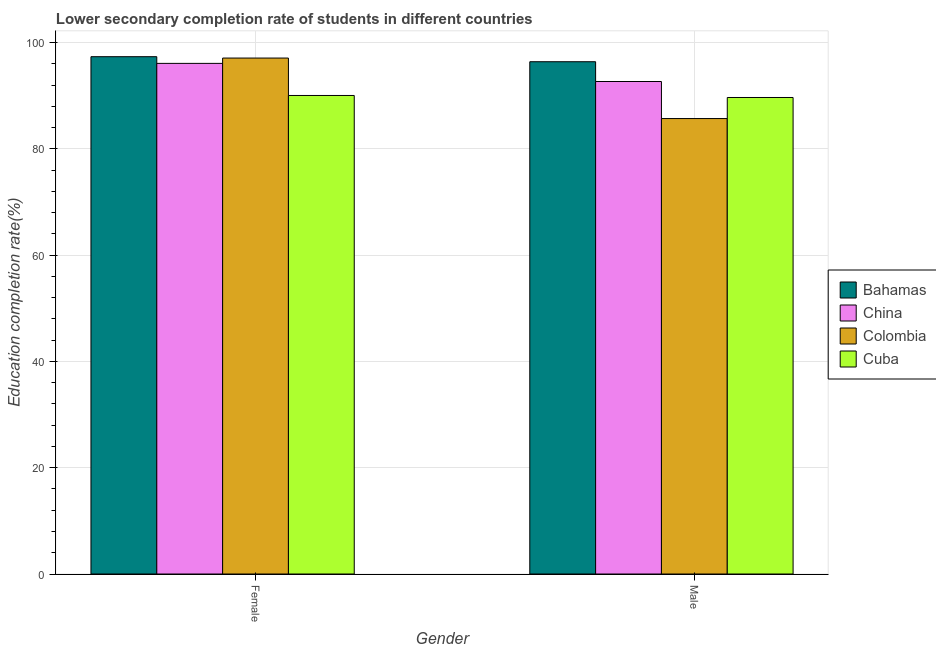How many different coloured bars are there?
Your answer should be very brief. 4. How many bars are there on the 1st tick from the left?
Your answer should be very brief. 4. How many bars are there on the 1st tick from the right?
Your answer should be compact. 4. What is the education completion rate of male students in China?
Your answer should be very brief. 92.69. Across all countries, what is the maximum education completion rate of male students?
Keep it short and to the point. 96.41. Across all countries, what is the minimum education completion rate of male students?
Your answer should be very brief. 85.72. In which country was the education completion rate of female students maximum?
Offer a very short reply. Bahamas. In which country was the education completion rate of male students minimum?
Your answer should be compact. Colombia. What is the total education completion rate of male students in the graph?
Make the answer very short. 364.5. What is the difference between the education completion rate of male students in Colombia and that in Bahamas?
Ensure brevity in your answer.  -10.69. What is the difference between the education completion rate of male students in Colombia and the education completion rate of female students in China?
Your response must be concise. -10.38. What is the average education completion rate of male students per country?
Give a very brief answer. 91.13. What is the difference between the education completion rate of male students and education completion rate of female students in Bahamas?
Make the answer very short. -0.95. In how many countries, is the education completion rate of male students greater than 92 %?
Ensure brevity in your answer.  2. What is the ratio of the education completion rate of male students in China to that in Colombia?
Give a very brief answer. 1.08. Is the education completion rate of female students in China less than that in Colombia?
Make the answer very short. Yes. In how many countries, is the education completion rate of female students greater than the average education completion rate of female students taken over all countries?
Provide a succinct answer. 3. How many bars are there?
Provide a short and direct response. 8. How many countries are there in the graph?
Give a very brief answer. 4. What is the difference between two consecutive major ticks on the Y-axis?
Provide a succinct answer. 20. Are the values on the major ticks of Y-axis written in scientific E-notation?
Offer a terse response. No. How many legend labels are there?
Ensure brevity in your answer.  4. What is the title of the graph?
Your answer should be compact. Lower secondary completion rate of students in different countries. What is the label or title of the Y-axis?
Provide a short and direct response. Education completion rate(%). What is the Education completion rate(%) in Bahamas in Female?
Offer a terse response. 97.36. What is the Education completion rate(%) of China in Female?
Make the answer very short. 96.1. What is the Education completion rate(%) in Colombia in Female?
Give a very brief answer. 97.11. What is the Education completion rate(%) of Cuba in Female?
Offer a very short reply. 90.06. What is the Education completion rate(%) of Bahamas in Male?
Your response must be concise. 96.41. What is the Education completion rate(%) of China in Male?
Make the answer very short. 92.69. What is the Education completion rate(%) of Colombia in Male?
Your answer should be very brief. 85.72. What is the Education completion rate(%) of Cuba in Male?
Offer a terse response. 89.68. Across all Gender, what is the maximum Education completion rate(%) in Bahamas?
Give a very brief answer. 97.36. Across all Gender, what is the maximum Education completion rate(%) in China?
Your answer should be very brief. 96.1. Across all Gender, what is the maximum Education completion rate(%) of Colombia?
Give a very brief answer. 97.11. Across all Gender, what is the maximum Education completion rate(%) in Cuba?
Give a very brief answer. 90.06. Across all Gender, what is the minimum Education completion rate(%) of Bahamas?
Provide a succinct answer. 96.41. Across all Gender, what is the minimum Education completion rate(%) in China?
Your response must be concise. 92.69. Across all Gender, what is the minimum Education completion rate(%) of Colombia?
Make the answer very short. 85.72. Across all Gender, what is the minimum Education completion rate(%) of Cuba?
Give a very brief answer. 89.68. What is the total Education completion rate(%) in Bahamas in the graph?
Provide a succinct answer. 193.77. What is the total Education completion rate(%) of China in the graph?
Offer a terse response. 188.79. What is the total Education completion rate(%) of Colombia in the graph?
Your answer should be compact. 182.82. What is the total Education completion rate(%) of Cuba in the graph?
Provide a short and direct response. 179.74. What is the difference between the Education completion rate(%) of Bahamas in Female and that in Male?
Give a very brief answer. 0.95. What is the difference between the Education completion rate(%) in China in Female and that in Male?
Offer a very short reply. 3.41. What is the difference between the Education completion rate(%) of Colombia in Female and that in Male?
Make the answer very short. 11.39. What is the difference between the Education completion rate(%) in Cuba in Female and that in Male?
Give a very brief answer. 0.38. What is the difference between the Education completion rate(%) of Bahamas in Female and the Education completion rate(%) of China in Male?
Ensure brevity in your answer.  4.67. What is the difference between the Education completion rate(%) of Bahamas in Female and the Education completion rate(%) of Colombia in Male?
Provide a short and direct response. 11.64. What is the difference between the Education completion rate(%) of Bahamas in Female and the Education completion rate(%) of Cuba in Male?
Provide a short and direct response. 7.68. What is the difference between the Education completion rate(%) of China in Female and the Education completion rate(%) of Colombia in Male?
Your response must be concise. 10.38. What is the difference between the Education completion rate(%) of China in Female and the Education completion rate(%) of Cuba in Male?
Your answer should be compact. 6.42. What is the difference between the Education completion rate(%) in Colombia in Female and the Education completion rate(%) in Cuba in Male?
Provide a short and direct response. 7.42. What is the average Education completion rate(%) of Bahamas per Gender?
Give a very brief answer. 96.89. What is the average Education completion rate(%) of China per Gender?
Your answer should be very brief. 94.39. What is the average Education completion rate(%) of Colombia per Gender?
Your answer should be compact. 91.41. What is the average Education completion rate(%) of Cuba per Gender?
Ensure brevity in your answer.  89.87. What is the difference between the Education completion rate(%) in Bahamas and Education completion rate(%) in China in Female?
Your response must be concise. 1.26. What is the difference between the Education completion rate(%) in Bahamas and Education completion rate(%) in Colombia in Female?
Provide a succinct answer. 0.26. What is the difference between the Education completion rate(%) in Bahamas and Education completion rate(%) in Cuba in Female?
Your answer should be compact. 7.3. What is the difference between the Education completion rate(%) of China and Education completion rate(%) of Colombia in Female?
Your response must be concise. -1.01. What is the difference between the Education completion rate(%) of China and Education completion rate(%) of Cuba in Female?
Offer a very short reply. 6.04. What is the difference between the Education completion rate(%) of Colombia and Education completion rate(%) of Cuba in Female?
Offer a terse response. 7.04. What is the difference between the Education completion rate(%) of Bahamas and Education completion rate(%) of China in Male?
Your answer should be compact. 3.72. What is the difference between the Education completion rate(%) of Bahamas and Education completion rate(%) of Colombia in Male?
Provide a short and direct response. 10.69. What is the difference between the Education completion rate(%) in Bahamas and Education completion rate(%) in Cuba in Male?
Your answer should be compact. 6.73. What is the difference between the Education completion rate(%) of China and Education completion rate(%) of Colombia in Male?
Keep it short and to the point. 6.97. What is the difference between the Education completion rate(%) in China and Education completion rate(%) in Cuba in Male?
Your answer should be compact. 3.01. What is the difference between the Education completion rate(%) in Colombia and Education completion rate(%) in Cuba in Male?
Provide a short and direct response. -3.96. What is the ratio of the Education completion rate(%) of Bahamas in Female to that in Male?
Your answer should be compact. 1.01. What is the ratio of the Education completion rate(%) in China in Female to that in Male?
Offer a terse response. 1.04. What is the ratio of the Education completion rate(%) of Colombia in Female to that in Male?
Make the answer very short. 1.13. What is the difference between the highest and the second highest Education completion rate(%) in Bahamas?
Make the answer very short. 0.95. What is the difference between the highest and the second highest Education completion rate(%) in China?
Your answer should be compact. 3.41. What is the difference between the highest and the second highest Education completion rate(%) of Colombia?
Ensure brevity in your answer.  11.39. What is the difference between the highest and the second highest Education completion rate(%) of Cuba?
Make the answer very short. 0.38. What is the difference between the highest and the lowest Education completion rate(%) in Bahamas?
Your response must be concise. 0.95. What is the difference between the highest and the lowest Education completion rate(%) of China?
Your response must be concise. 3.41. What is the difference between the highest and the lowest Education completion rate(%) of Colombia?
Ensure brevity in your answer.  11.39. What is the difference between the highest and the lowest Education completion rate(%) of Cuba?
Your answer should be compact. 0.38. 